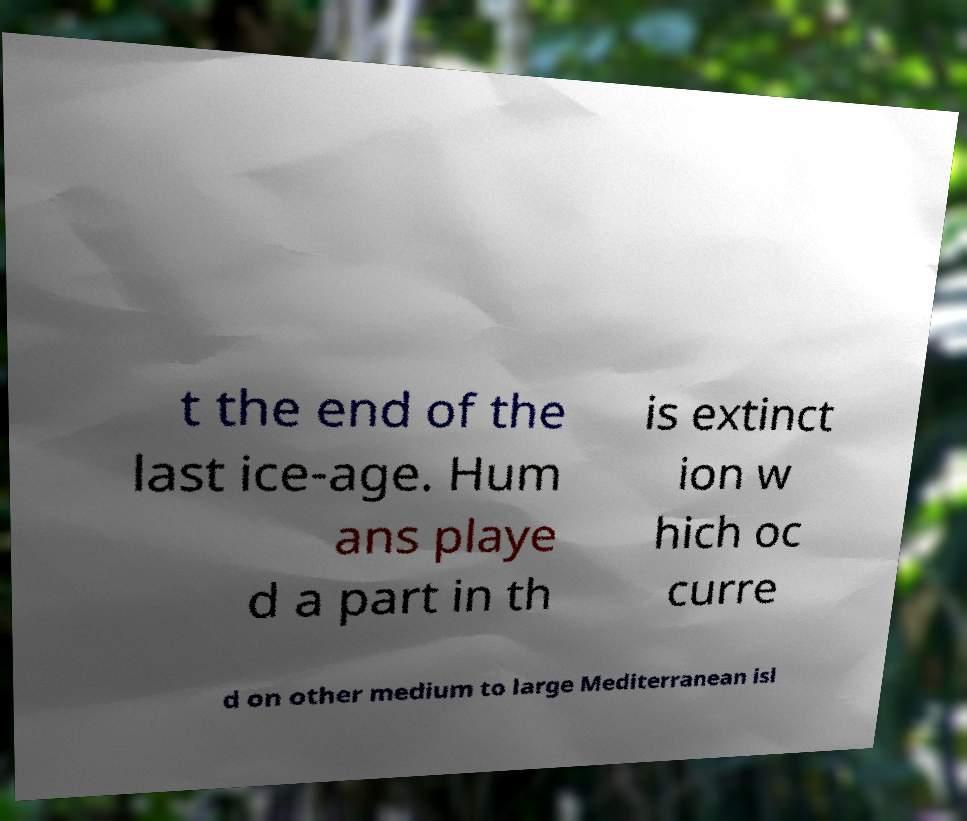For documentation purposes, I need the text within this image transcribed. Could you provide that? t the end of the last ice-age. Hum ans playe d a part in th is extinct ion w hich oc curre d on other medium to large Mediterranean isl 